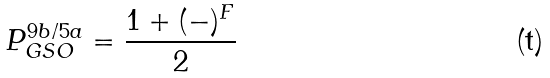<formula> <loc_0><loc_0><loc_500><loc_500>P _ { G S O } ^ { 9 b / 5 a } = \frac { 1 + ( - ) ^ { F } } { 2 }</formula> 